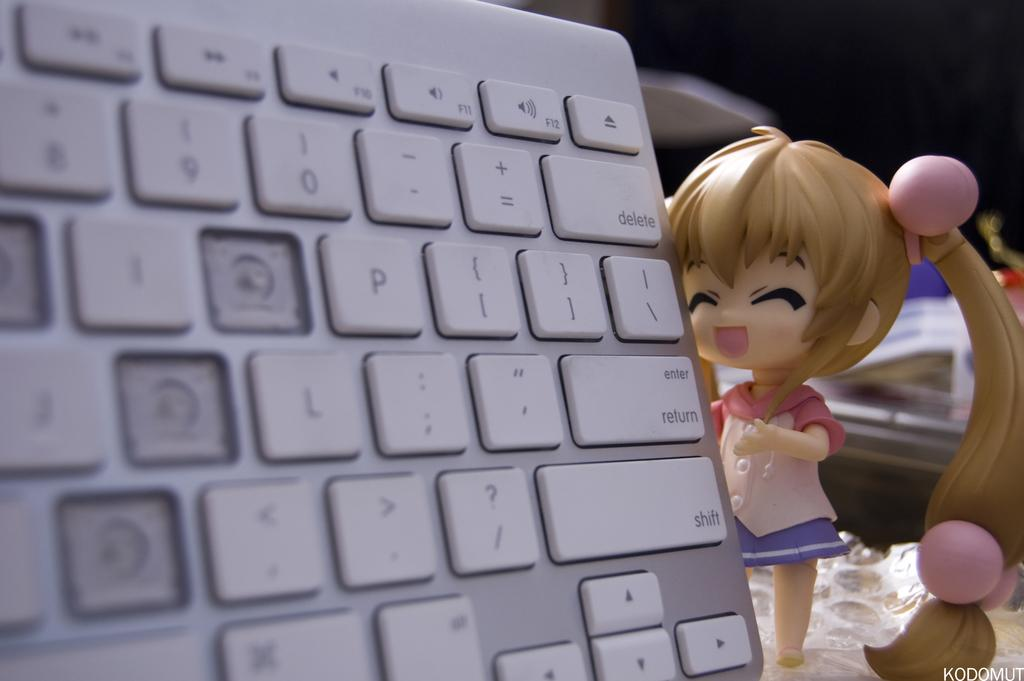What type of device is visible in the image? There is a part of a keyboard with white color buttons in the image. What other object is present near the keyboard? There is a girl doll beside the keyboard. Can you describe the objects placed behind the keyboard and the doll? Unfortunately, the facts provided do not give any information about the objects placed behind the keyboard and the doll. How does the girl doll use the mitten in the image? There is no mitten present in the image. What type of amusement can be seen in the image? The image does not depict any amusement; it features a part of a keyboard and a girl doll. 